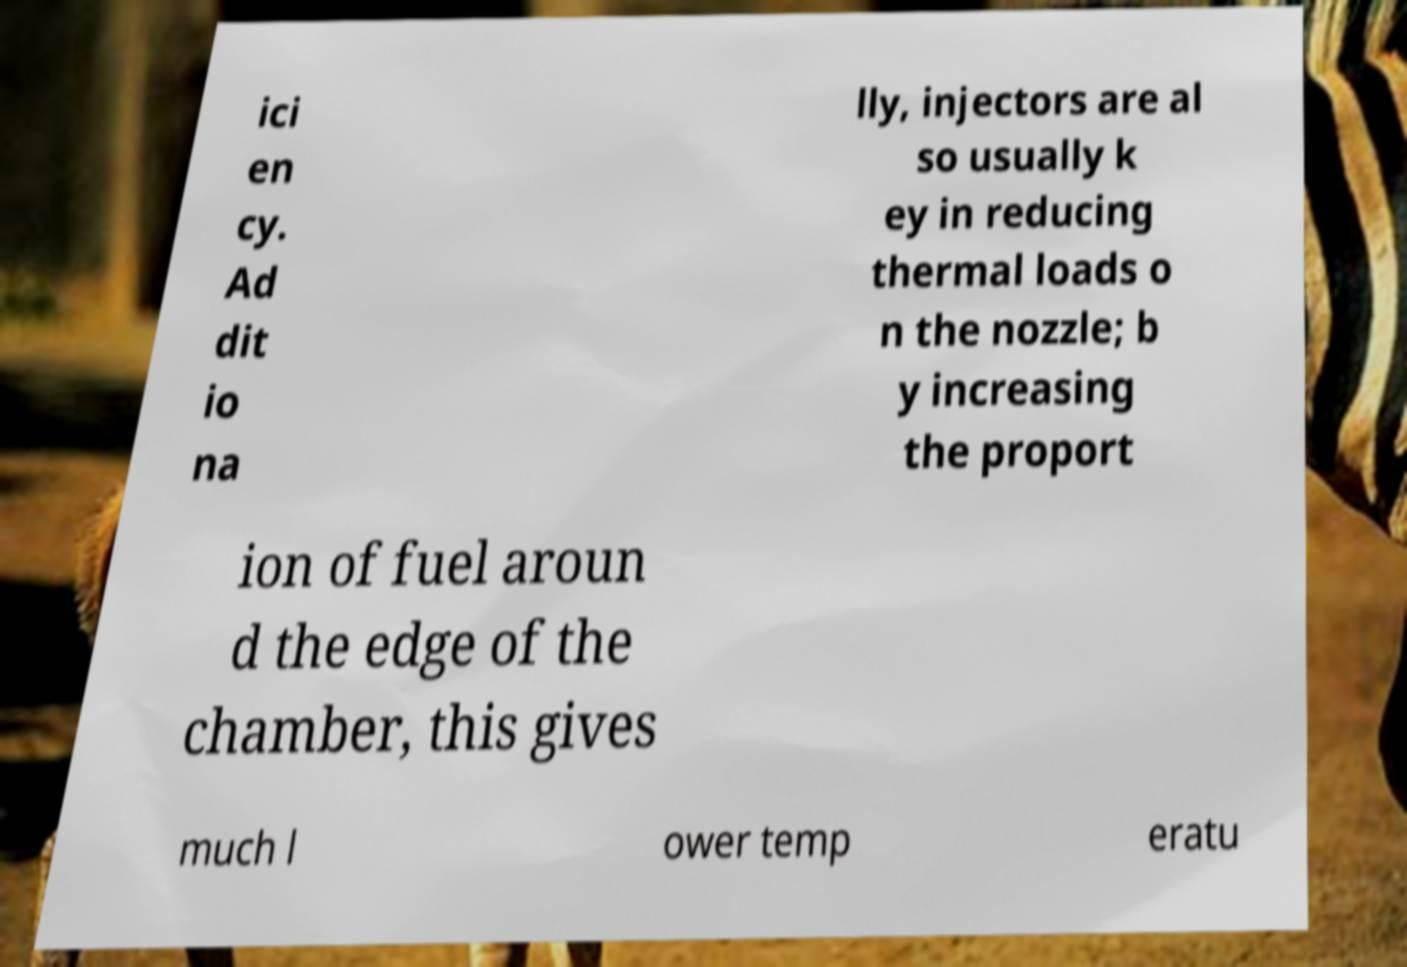What messages or text are displayed in this image? I need them in a readable, typed format. ici en cy. Ad dit io na lly, injectors are al so usually k ey in reducing thermal loads o n the nozzle; b y increasing the proport ion of fuel aroun d the edge of the chamber, this gives much l ower temp eratu 